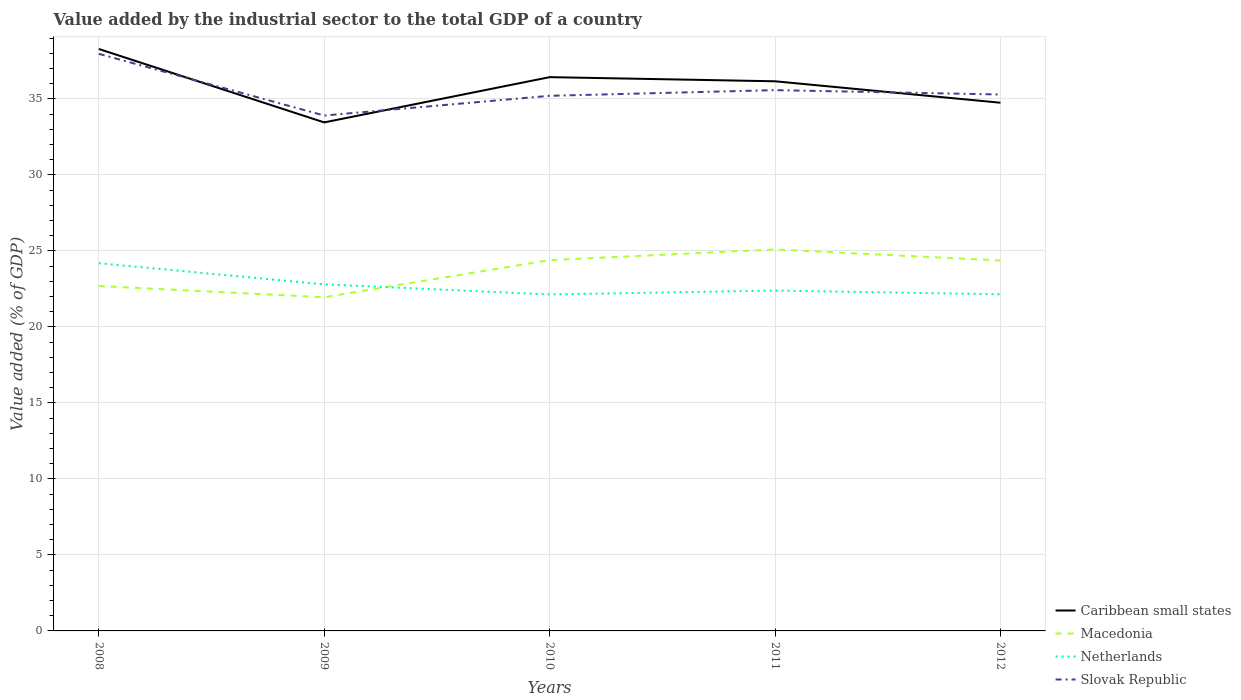How many different coloured lines are there?
Make the answer very short. 4. Is the number of lines equal to the number of legend labels?
Provide a short and direct response. Yes. Across all years, what is the maximum value added by the industrial sector to the total GDP in Slovak Republic?
Offer a very short reply. 33.91. What is the total value added by the industrial sector to the total GDP in Caribbean small states in the graph?
Keep it short and to the point. 4.83. What is the difference between the highest and the second highest value added by the industrial sector to the total GDP in Netherlands?
Your answer should be very brief. 2.05. What is the difference between the highest and the lowest value added by the industrial sector to the total GDP in Caribbean small states?
Offer a terse response. 3. Are the values on the major ticks of Y-axis written in scientific E-notation?
Provide a succinct answer. No. Does the graph contain grids?
Offer a terse response. Yes. How many legend labels are there?
Your answer should be very brief. 4. How are the legend labels stacked?
Offer a very short reply. Vertical. What is the title of the graph?
Provide a succinct answer. Value added by the industrial sector to the total GDP of a country. Does "Slovenia" appear as one of the legend labels in the graph?
Provide a short and direct response. No. What is the label or title of the X-axis?
Give a very brief answer. Years. What is the label or title of the Y-axis?
Your answer should be very brief. Value added (% of GDP). What is the Value added (% of GDP) of Caribbean small states in 2008?
Your answer should be very brief. 38.28. What is the Value added (% of GDP) in Macedonia in 2008?
Provide a short and direct response. 22.69. What is the Value added (% of GDP) of Netherlands in 2008?
Your answer should be compact. 24.19. What is the Value added (% of GDP) of Slovak Republic in 2008?
Your answer should be very brief. 37.97. What is the Value added (% of GDP) in Caribbean small states in 2009?
Your answer should be very brief. 33.45. What is the Value added (% of GDP) of Macedonia in 2009?
Ensure brevity in your answer.  21.95. What is the Value added (% of GDP) in Netherlands in 2009?
Ensure brevity in your answer.  22.8. What is the Value added (% of GDP) of Slovak Republic in 2009?
Keep it short and to the point. 33.91. What is the Value added (% of GDP) of Caribbean small states in 2010?
Make the answer very short. 36.43. What is the Value added (% of GDP) of Macedonia in 2010?
Provide a succinct answer. 24.4. What is the Value added (% of GDP) of Netherlands in 2010?
Your response must be concise. 22.14. What is the Value added (% of GDP) of Slovak Republic in 2010?
Your answer should be compact. 35.2. What is the Value added (% of GDP) of Caribbean small states in 2011?
Your answer should be very brief. 36.16. What is the Value added (% of GDP) in Macedonia in 2011?
Your answer should be very brief. 25.1. What is the Value added (% of GDP) of Netherlands in 2011?
Give a very brief answer. 22.39. What is the Value added (% of GDP) of Slovak Republic in 2011?
Give a very brief answer. 35.58. What is the Value added (% of GDP) of Caribbean small states in 2012?
Your answer should be compact. 34.75. What is the Value added (% of GDP) of Macedonia in 2012?
Offer a very short reply. 24.37. What is the Value added (% of GDP) in Netherlands in 2012?
Offer a very short reply. 22.14. What is the Value added (% of GDP) in Slovak Republic in 2012?
Make the answer very short. 35.29. Across all years, what is the maximum Value added (% of GDP) in Caribbean small states?
Keep it short and to the point. 38.28. Across all years, what is the maximum Value added (% of GDP) in Macedonia?
Give a very brief answer. 25.1. Across all years, what is the maximum Value added (% of GDP) of Netherlands?
Offer a very short reply. 24.19. Across all years, what is the maximum Value added (% of GDP) of Slovak Republic?
Offer a terse response. 37.97. Across all years, what is the minimum Value added (% of GDP) in Caribbean small states?
Your answer should be compact. 33.45. Across all years, what is the minimum Value added (% of GDP) in Macedonia?
Your response must be concise. 21.95. Across all years, what is the minimum Value added (% of GDP) in Netherlands?
Your answer should be compact. 22.14. Across all years, what is the minimum Value added (% of GDP) of Slovak Republic?
Your answer should be compact. 33.91. What is the total Value added (% of GDP) in Caribbean small states in the graph?
Ensure brevity in your answer.  179.08. What is the total Value added (% of GDP) of Macedonia in the graph?
Provide a short and direct response. 118.5. What is the total Value added (% of GDP) in Netherlands in the graph?
Give a very brief answer. 113.66. What is the total Value added (% of GDP) in Slovak Republic in the graph?
Offer a terse response. 177.94. What is the difference between the Value added (% of GDP) of Caribbean small states in 2008 and that in 2009?
Your response must be concise. 4.83. What is the difference between the Value added (% of GDP) in Macedonia in 2008 and that in 2009?
Offer a terse response. 0.74. What is the difference between the Value added (% of GDP) of Netherlands in 2008 and that in 2009?
Ensure brevity in your answer.  1.39. What is the difference between the Value added (% of GDP) of Slovak Republic in 2008 and that in 2009?
Give a very brief answer. 4.06. What is the difference between the Value added (% of GDP) in Caribbean small states in 2008 and that in 2010?
Your answer should be very brief. 1.85. What is the difference between the Value added (% of GDP) of Macedonia in 2008 and that in 2010?
Your answer should be compact. -1.7. What is the difference between the Value added (% of GDP) in Netherlands in 2008 and that in 2010?
Your answer should be compact. 2.05. What is the difference between the Value added (% of GDP) in Slovak Republic in 2008 and that in 2010?
Your answer should be compact. 2.76. What is the difference between the Value added (% of GDP) of Caribbean small states in 2008 and that in 2011?
Your answer should be very brief. 2.12. What is the difference between the Value added (% of GDP) in Macedonia in 2008 and that in 2011?
Your response must be concise. -2.41. What is the difference between the Value added (% of GDP) of Netherlands in 2008 and that in 2011?
Offer a very short reply. 1.8. What is the difference between the Value added (% of GDP) in Slovak Republic in 2008 and that in 2011?
Your answer should be compact. 2.39. What is the difference between the Value added (% of GDP) in Caribbean small states in 2008 and that in 2012?
Keep it short and to the point. 3.54. What is the difference between the Value added (% of GDP) in Macedonia in 2008 and that in 2012?
Offer a very short reply. -1.68. What is the difference between the Value added (% of GDP) in Netherlands in 2008 and that in 2012?
Give a very brief answer. 2.05. What is the difference between the Value added (% of GDP) in Slovak Republic in 2008 and that in 2012?
Ensure brevity in your answer.  2.68. What is the difference between the Value added (% of GDP) of Caribbean small states in 2009 and that in 2010?
Make the answer very short. -2.98. What is the difference between the Value added (% of GDP) in Macedonia in 2009 and that in 2010?
Provide a short and direct response. -2.44. What is the difference between the Value added (% of GDP) of Netherlands in 2009 and that in 2010?
Offer a terse response. 0.66. What is the difference between the Value added (% of GDP) in Slovak Republic in 2009 and that in 2010?
Your response must be concise. -1.3. What is the difference between the Value added (% of GDP) in Caribbean small states in 2009 and that in 2011?
Offer a terse response. -2.71. What is the difference between the Value added (% of GDP) of Macedonia in 2009 and that in 2011?
Your answer should be compact. -3.15. What is the difference between the Value added (% of GDP) of Netherlands in 2009 and that in 2011?
Make the answer very short. 0.41. What is the difference between the Value added (% of GDP) in Slovak Republic in 2009 and that in 2011?
Provide a short and direct response. -1.67. What is the difference between the Value added (% of GDP) of Caribbean small states in 2009 and that in 2012?
Ensure brevity in your answer.  -1.29. What is the difference between the Value added (% of GDP) of Macedonia in 2009 and that in 2012?
Your answer should be compact. -2.42. What is the difference between the Value added (% of GDP) in Netherlands in 2009 and that in 2012?
Offer a terse response. 0.66. What is the difference between the Value added (% of GDP) of Slovak Republic in 2009 and that in 2012?
Make the answer very short. -1.38. What is the difference between the Value added (% of GDP) in Caribbean small states in 2010 and that in 2011?
Provide a succinct answer. 0.27. What is the difference between the Value added (% of GDP) in Macedonia in 2010 and that in 2011?
Ensure brevity in your answer.  -0.7. What is the difference between the Value added (% of GDP) in Netherlands in 2010 and that in 2011?
Give a very brief answer. -0.25. What is the difference between the Value added (% of GDP) of Slovak Republic in 2010 and that in 2011?
Offer a terse response. -0.37. What is the difference between the Value added (% of GDP) of Caribbean small states in 2010 and that in 2012?
Keep it short and to the point. 1.68. What is the difference between the Value added (% of GDP) in Macedonia in 2010 and that in 2012?
Your response must be concise. 0.02. What is the difference between the Value added (% of GDP) of Netherlands in 2010 and that in 2012?
Offer a terse response. -0.01. What is the difference between the Value added (% of GDP) of Slovak Republic in 2010 and that in 2012?
Offer a terse response. -0.09. What is the difference between the Value added (% of GDP) of Caribbean small states in 2011 and that in 2012?
Ensure brevity in your answer.  1.41. What is the difference between the Value added (% of GDP) in Macedonia in 2011 and that in 2012?
Offer a terse response. 0.72. What is the difference between the Value added (% of GDP) of Netherlands in 2011 and that in 2012?
Your answer should be very brief. 0.25. What is the difference between the Value added (% of GDP) of Slovak Republic in 2011 and that in 2012?
Keep it short and to the point. 0.29. What is the difference between the Value added (% of GDP) of Caribbean small states in 2008 and the Value added (% of GDP) of Macedonia in 2009?
Keep it short and to the point. 16.33. What is the difference between the Value added (% of GDP) in Caribbean small states in 2008 and the Value added (% of GDP) in Netherlands in 2009?
Ensure brevity in your answer.  15.48. What is the difference between the Value added (% of GDP) in Caribbean small states in 2008 and the Value added (% of GDP) in Slovak Republic in 2009?
Offer a very short reply. 4.38. What is the difference between the Value added (% of GDP) of Macedonia in 2008 and the Value added (% of GDP) of Netherlands in 2009?
Keep it short and to the point. -0.11. What is the difference between the Value added (% of GDP) in Macedonia in 2008 and the Value added (% of GDP) in Slovak Republic in 2009?
Offer a terse response. -11.22. What is the difference between the Value added (% of GDP) of Netherlands in 2008 and the Value added (% of GDP) of Slovak Republic in 2009?
Give a very brief answer. -9.72. What is the difference between the Value added (% of GDP) of Caribbean small states in 2008 and the Value added (% of GDP) of Macedonia in 2010?
Provide a succinct answer. 13.89. What is the difference between the Value added (% of GDP) of Caribbean small states in 2008 and the Value added (% of GDP) of Netherlands in 2010?
Give a very brief answer. 16.15. What is the difference between the Value added (% of GDP) in Caribbean small states in 2008 and the Value added (% of GDP) in Slovak Republic in 2010?
Ensure brevity in your answer.  3.08. What is the difference between the Value added (% of GDP) in Macedonia in 2008 and the Value added (% of GDP) in Netherlands in 2010?
Provide a short and direct response. 0.55. What is the difference between the Value added (% of GDP) in Macedonia in 2008 and the Value added (% of GDP) in Slovak Republic in 2010?
Ensure brevity in your answer.  -12.51. What is the difference between the Value added (% of GDP) of Netherlands in 2008 and the Value added (% of GDP) of Slovak Republic in 2010?
Provide a succinct answer. -11.02. What is the difference between the Value added (% of GDP) of Caribbean small states in 2008 and the Value added (% of GDP) of Macedonia in 2011?
Keep it short and to the point. 13.19. What is the difference between the Value added (% of GDP) of Caribbean small states in 2008 and the Value added (% of GDP) of Netherlands in 2011?
Provide a succinct answer. 15.89. What is the difference between the Value added (% of GDP) in Caribbean small states in 2008 and the Value added (% of GDP) in Slovak Republic in 2011?
Offer a terse response. 2.71. What is the difference between the Value added (% of GDP) of Macedonia in 2008 and the Value added (% of GDP) of Netherlands in 2011?
Offer a terse response. 0.3. What is the difference between the Value added (% of GDP) in Macedonia in 2008 and the Value added (% of GDP) in Slovak Republic in 2011?
Ensure brevity in your answer.  -12.89. What is the difference between the Value added (% of GDP) in Netherlands in 2008 and the Value added (% of GDP) in Slovak Republic in 2011?
Provide a succinct answer. -11.39. What is the difference between the Value added (% of GDP) in Caribbean small states in 2008 and the Value added (% of GDP) in Macedonia in 2012?
Keep it short and to the point. 13.91. What is the difference between the Value added (% of GDP) of Caribbean small states in 2008 and the Value added (% of GDP) of Netherlands in 2012?
Your answer should be very brief. 16.14. What is the difference between the Value added (% of GDP) of Caribbean small states in 2008 and the Value added (% of GDP) of Slovak Republic in 2012?
Your answer should be compact. 2.99. What is the difference between the Value added (% of GDP) of Macedonia in 2008 and the Value added (% of GDP) of Netherlands in 2012?
Your answer should be very brief. 0.55. What is the difference between the Value added (% of GDP) of Macedonia in 2008 and the Value added (% of GDP) of Slovak Republic in 2012?
Offer a very short reply. -12.6. What is the difference between the Value added (% of GDP) in Netherlands in 2008 and the Value added (% of GDP) in Slovak Republic in 2012?
Provide a succinct answer. -11.1. What is the difference between the Value added (% of GDP) in Caribbean small states in 2009 and the Value added (% of GDP) in Macedonia in 2010?
Provide a short and direct response. 9.06. What is the difference between the Value added (% of GDP) in Caribbean small states in 2009 and the Value added (% of GDP) in Netherlands in 2010?
Give a very brief answer. 11.32. What is the difference between the Value added (% of GDP) in Caribbean small states in 2009 and the Value added (% of GDP) in Slovak Republic in 2010?
Ensure brevity in your answer.  -1.75. What is the difference between the Value added (% of GDP) of Macedonia in 2009 and the Value added (% of GDP) of Netherlands in 2010?
Keep it short and to the point. -0.19. What is the difference between the Value added (% of GDP) in Macedonia in 2009 and the Value added (% of GDP) in Slovak Republic in 2010?
Ensure brevity in your answer.  -13.25. What is the difference between the Value added (% of GDP) in Netherlands in 2009 and the Value added (% of GDP) in Slovak Republic in 2010?
Provide a succinct answer. -12.4. What is the difference between the Value added (% of GDP) in Caribbean small states in 2009 and the Value added (% of GDP) in Macedonia in 2011?
Your answer should be very brief. 8.36. What is the difference between the Value added (% of GDP) in Caribbean small states in 2009 and the Value added (% of GDP) in Netherlands in 2011?
Your response must be concise. 11.06. What is the difference between the Value added (% of GDP) of Caribbean small states in 2009 and the Value added (% of GDP) of Slovak Republic in 2011?
Give a very brief answer. -2.12. What is the difference between the Value added (% of GDP) in Macedonia in 2009 and the Value added (% of GDP) in Netherlands in 2011?
Make the answer very short. -0.44. What is the difference between the Value added (% of GDP) in Macedonia in 2009 and the Value added (% of GDP) in Slovak Republic in 2011?
Provide a succinct answer. -13.63. What is the difference between the Value added (% of GDP) in Netherlands in 2009 and the Value added (% of GDP) in Slovak Republic in 2011?
Ensure brevity in your answer.  -12.78. What is the difference between the Value added (% of GDP) of Caribbean small states in 2009 and the Value added (% of GDP) of Macedonia in 2012?
Keep it short and to the point. 9.08. What is the difference between the Value added (% of GDP) in Caribbean small states in 2009 and the Value added (% of GDP) in Netherlands in 2012?
Offer a very short reply. 11.31. What is the difference between the Value added (% of GDP) in Caribbean small states in 2009 and the Value added (% of GDP) in Slovak Republic in 2012?
Give a very brief answer. -1.84. What is the difference between the Value added (% of GDP) in Macedonia in 2009 and the Value added (% of GDP) in Netherlands in 2012?
Give a very brief answer. -0.19. What is the difference between the Value added (% of GDP) in Macedonia in 2009 and the Value added (% of GDP) in Slovak Republic in 2012?
Provide a short and direct response. -13.34. What is the difference between the Value added (% of GDP) in Netherlands in 2009 and the Value added (% of GDP) in Slovak Republic in 2012?
Offer a very short reply. -12.49. What is the difference between the Value added (% of GDP) of Caribbean small states in 2010 and the Value added (% of GDP) of Macedonia in 2011?
Offer a terse response. 11.34. What is the difference between the Value added (% of GDP) of Caribbean small states in 2010 and the Value added (% of GDP) of Netherlands in 2011?
Provide a short and direct response. 14.04. What is the difference between the Value added (% of GDP) of Caribbean small states in 2010 and the Value added (% of GDP) of Slovak Republic in 2011?
Give a very brief answer. 0.85. What is the difference between the Value added (% of GDP) in Macedonia in 2010 and the Value added (% of GDP) in Netherlands in 2011?
Your answer should be very brief. 2. What is the difference between the Value added (% of GDP) of Macedonia in 2010 and the Value added (% of GDP) of Slovak Republic in 2011?
Provide a succinct answer. -11.18. What is the difference between the Value added (% of GDP) of Netherlands in 2010 and the Value added (% of GDP) of Slovak Republic in 2011?
Keep it short and to the point. -13.44. What is the difference between the Value added (% of GDP) in Caribbean small states in 2010 and the Value added (% of GDP) in Macedonia in 2012?
Make the answer very short. 12.06. What is the difference between the Value added (% of GDP) of Caribbean small states in 2010 and the Value added (% of GDP) of Netherlands in 2012?
Your answer should be very brief. 14.29. What is the difference between the Value added (% of GDP) in Caribbean small states in 2010 and the Value added (% of GDP) in Slovak Republic in 2012?
Make the answer very short. 1.14. What is the difference between the Value added (% of GDP) in Macedonia in 2010 and the Value added (% of GDP) in Netherlands in 2012?
Your answer should be very brief. 2.25. What is the difference between the Value added (% of GDP) of Macedonia in 2010 and the Value added (% of GDP) of Slovak Republic in 2012?
Offer a terse response. -10.89. What is the difference between the Value added (% of GDP) of Netherlands in 2010 and the Value added (% of GDP) of Slovak Republic in 2012?
Your response must be concise. -13.15. What is the difference between the Value added (% of GDP) in Caribbean small states in 2011 and the Value added (% of GDP) in Macedonia in 2012?
Offer a very short reply. 11.79. What is the difference between the Value added (% of GDP) in Caribbean small states in 2011 and the Value added (% of GDP) in Netherlands in 2012?
Offer a very short reply. 14.02. What is the difference between the Value added (% of GDP) of Caribbean small states in 2011 and the Value added (% of GDP) of Slovak Republic in 2012?
Provide a short and direct response. 0.87. What is the difference between the Value added (% of GDP) in Macedonia in 2011 and the Value added (% of GDP) in Netherlands in 2012?
Ensure brevity in your answer.  2.95. What is the difference between the Value added (% of GDP) of Macedonia in 2011 and the Value added (% of GDP) of Slovak Republic in 2012?
Keep it short and to the point. -10.19. What is the difference between the Value added (% of GDP) in Netherlands in 2011 and the Value added (% of GDP) in Slovak Republic in 2012?
Your answer should be compact. -12.9. What is the average Value added (% of GDP) of Caribbean small states per year?
Offer a very short reply. 35.82. What is the average Value added (% of GDP) of Macedonia per year?
Make the answer very short. 23.7. What is the average Value added (% of GDP) in Netherlands per year?
Give a very brief answer. 22.73. What is the average Value added (% of GDP) of Slovak Republic per year?
Your answer should be very brief. 35.59. In the year 2008, what is the difference between the Value added (% of GDP) of Caribbean small states and Value added (% of GDP) of Macedonia?
Offer a very short reply. 15.59. In the year 2008, what is the difference between the Value added (% of GDP) of Caribbean small states and Value added (% of GDP) of Netherlands?
Keep it short and to the point. 14.1. In the year 2008, what is the difference between the Value added (% of GDP) of Caribbean small states and Value added (% of GDP) of Slovak Republic?
Offer a very short reply. 0.32. In the year 2008, what is the difference between the Value added (% of GDP) in Macedonia and Value added (% of GDP) in Netherlands?
Give a very brief answer. -1.5. In the year 2008, what is the difference between the Value added (% of GDP) in Macedonia and Value added (% of GDP) in Slovak Republic?
Offer a very short reply. -15.28. In the year 2008, what is the difference between the Value added (% of GDP) of Netherlands and Value added (% of GDP) of Slovak Republic?
Make the answer very short. -13.78. In the year 2009, what is the difference between the Value added (% of GDP) in Caribbean small states and Value added (% of GDP) in Macedonia?
Provide a short and direct response. 11.5. In the year 2009, what is the difference between the Value added (% of GDP) in Caribbean small states and Value added (% of GDP) in Netherlands?
Offer a terse response. 10.65. In the year 2009, what is the difference between the Value added (% of GDP) in Caribbean small states and Value added (% of GDP) in Slovak Republic?
Provide a short and direct response. -0.45. In the year 2009, what is the difference between the Value added (% of GDP) in Macedonia and Value added (% of GDP) in Netherlands?
Your answer should be compact. -0.85. In the year 2009, what is the difference between the Value added (% of GDP) of Macedonia and Value added (% of GDP) of Slovak Republic?
Offer a terse response. -11.96. In the year 2009, what is the difference between the Value added (% of GDP) in Netherlands and Value added (% of GDP) in Slovak Republic?
Keep it short and to the point. -11.11. In the year 2010, what is the difference between the Value added (% of GDP) of Caribbean small states and Value added (% of GDP) of Macedonia?
Provide a short and direct response. 12.04. In the year 2010, what is the difference between the Value added (% of GDP) of Caribbean small states and Value added (% of GDP) of Netherlands?
Provide a succinct answer. 14.3. In the year 2010, what is the difference between the Value added (% of GDP) of Caribbean small states and Value added (% of GDP) of Slovak Republic?
Provide a short and direct response. 1.23. In the year 2010, what is the difference between the Value added (% of GDP) in Macedonia and Value added (% of GDP) in Netherlands?
Ensure brevity in your answer.  2.26. In the year 2010, what is the difference between the Value added (% of GDP) of Macedonia and Value added (% of GDP) of Slovak Republic?
Your answer should be compact. -10.81. In the year 2010, what is the difference between the Value added (% of GDP) of Netherlands and Value added (% of GDP) of Slovak Republic?
Your answer should be very brief. -13.07. In the year 2011, what is the difference between the Value added (% of GDP) in Caribbean small states and Value added (% of GDP) in Macedonia?
Provide a succinct answer. 11.06. In the year 2011, what is the difference between the Value added (% of GDP) of Caribbean small states and Value added (% of GDP) of Netherlands?
Ensure brevity in your answer.  13.77. In the year 2011, what is the difference between the Value added (% of GDP) of Caribbean small states and Value added (% of GDP) of Slovak Republic?
Offer a terse response. 0.58. In the year 2011, what is the difference between the Value added (% of GDP) in Macedonia and Value added (% of GDP) in Netherlands?
Keep it short and to the point. 2.71. In the year 2011, what is the difference between the Value added (% of GDP) of Macedonia and Value added (% of GDP) of Slovak Republic?
Ensure brevity in your answer.  -10.48. In the year 2011, what is the difference between the Value added (% of GDP) in Netherlands and Value added (% of GDP) in Slovak Republic?
Offer a very short reply. -13.19. In the year 2012, what is the difference between the Value added (% of GDP) in Caribbean small states and Value added (% of GDP) in Macedonia?
Keep it short and to the point. 10.38. In the year 2012, what is the difference between the Value added (% of GDP) of Caribbean small states and Value added (% of GDP) of Netherlands?
Ensure brevity in your answer.  12.6. In the year 2012, what is the difference between the Value added (% of GDP) of Caribbean small states and Value added (% of GDP) of Slovak Republic?
Offer a very short reply. -0.54. In the year 2012, what is the difference between the Value added (% of GDP) of Macedonia and Value added (% of GDP) of Netherlands?
Offer a very short reply. 2.23. In the year 2012, what is the difference between the Value added (% of GDP) in Macedonia and Value added (% of GDP) in Slovak Republic?
Your response must be concise. -10.92. In the year 2012, what is the difference between the Value added (% of GDP) of Netherlands and Value added (% of GDP) of Slovak Republic?
Provide a succinct answer. -13.15. What is the ratio of the Value added (% of GDP) of Caribbean small states in 2008 to that in 2009?
Your answer should be compact. 1.14. What is the ratio of the Value added (% of GDP) in Macedonia in 2008 to that in 2009?
Give a very brief answer. 1.03. What is the ratio of the Value added (% of GDP) in Netherlands in 2008 to that in 2009?
Ensure brevity in your answer.  1.06. What is the ratio of the Value added (% of GDP) of Slovak Republic in 2008 to that in 2009?
Offer a very short reply. 1.12. What is the ratio of the Value added (% of GDP) in Caribbean small states in 2008 to that in 2010?
Your response must be concise. 1.05. What is the ratio of the Value added (% of GDP) in Macedonia in 2008 to that in 2010?
Your answer should be very brief. 0.93. What is the ratio of the Value added (% of GDP) in Netherlands in 2008 to that in 2010?
Ensure brevity in your answer.  1.09. What is the ratio of the Value added (% of GDP) of Slovak Republic in 2008 to that in 2010?
Provide a short and direct response. 1.08. What is the ratio of the Value added (% of GDP) of Caribbean small states in 2008 to that in 2011?
Make the answer very short. 1.06. What is the ratio of the Value added (% of GDP) in Macedonia in 2008 to that in 2011?
Give a very brief answer. 0.9. What is the ratio of the Value added (% of GDP) of Netherlands in 2008 to that in 2011?
Your answer should be compact. 1.08. What is the ratio of the Value added (% of GDP) of Slovak Republic in 2008 to that in 2011?
Ensure brevity in your answer.  1.07. What is the ratio of the Value added (% of GDP) in Caribbean small states in 2008 to that in 2012?
Ensure brevity in your answer.  1.1. What is the ratio of the Value added (% of GDP) in Macedonia in 2008 to that in 2012?
Offer a very short reply. 0.93. What is the ratio of the Value added (% of GDP) in Netherlands in 2008 to that in 2012?
Your response must be concise. 1.09. What is the ratio of the Value added (% of GDP) in Slovak Republic in 2008 to that in 2012?
Your response must be concise. 1.08. What is the ratio of the Value added (% of GDP) in Caribbean small states in 2009 to that in 2010?
Make the answer very short. 0.92. What is the ratio of the Value added (% of GDP) of Macedonia in 2009 to that in 2010?
Your answer should be compact. 0.9. What is the ratio of the Value added (% of GDP) of Slovak Republic in 2009 to that in 2010?
Ensure brevity in your answer.  0.96. What is the ratio of the Value added (% of GDP) in Caribbean small states in 2009 to that in 2011?
Your response must be concise. 0.93. What is the ratio of the Value added (% of GDP) of Macedonia in 2009 to that in 2011?
Offer a terse response. 0.87. What is the ratio of the Value added (% of GDP) in Netherlands in 2009 to that in 2011?
Give a very brief answer. 1.02. What is the ratio of the Value added (% of GDP) in Slovak Republic in 2009 to that in 2011?
Your answer should be compact. 0.95. What is the ratio of the Value added (% of GDP) in Caribbean small states in 2009 to that in 2012?
Ensure brevity in your answer.  0.96. What is the ratio of the Value added (% of GDP) in Macedonia in 2009 to that in 2012?
Your response must be concise. 0.9. What is the ratio of the Value added (% of GDP) of Netherlands in 2009 to that in 2012?
Offer a very short reply. 1.03. What is the ratio of the Value added (% of GDP) in Slovak Republic in 2009 to that in 2012?
Offer a terse response. 0.96. What is the ratio of the Value added (% of GDP) of Caribbean small states in 2010 to that in 2011?
Keep it short and to the point. 1.01. What is the ratio of the Value added (% of GDP) in Macedonia in 2010 to that in 2011?
Make the answer very short. 0.97. What is the ratio of the Value added (% of GDP) of Netherlands in 2010 to that in 2011?
Ensure brevity in your answer.  0.99. What is the ratio of the Value added (% of GDP) in Slovak Republic in 2010 to that in 2011?
Make the answer very short. 0.99. What is the ratio of the Value added (% of GDP) of Caribbean small states in 2010 to that in 2012?
Ensure brevity in your answer.  1.05. What is the ratio of the Value added (% of GDP) in Macedonia in 2010 to that in 2012?
Offer a very short reply. 1. What is the ratio of the Value added (% of GDP) of Netherlands in 2010 to that in 2012?
Give a very brief answer. 1. What is the ratio of the Value added (% of GDP) of Slovak Republic in 2010 to that in 2012?
Your answer should be very brief. 1. What is the ratio of the Value added (% of GDP) of Caribbean small states in 2011 to that in 2012?
Make the answer very short. 1.04. What is the ratio of the Value added (% of GDP) in Macedonia in 2011 to that in 2012?
Your answer should be compact. 1.03. What is the ratio of the Value added (% of GDP) in Netherlands in 2011 to that in 2012?
Offer a very short reply. 1.01. What is the ratio of the Value added (% of GDP) in Slovak Republic in 2011 to that in 2012?
Your answer should be compact. 1.01. What is the difference between the highest and the second highest Value added (% of GDP) in Caribbean small states?
Offer a very short reply. 1.85. What is the difference between the highest and the second highest Value added (% of GDP) of Macedonia?
Your answer should be compact. 0.7. What is the difference between the highest and the second highest Value added (% of GDP) of Netherlands?
Offer a terse response. 1.39. What is the difference between the highest and the second highest Value added (% of GDP) of Slovak Republic?
Your answer should be very brief. 2.39. What is the difference between the highest and the lowest Value added (% of GDP) of Caribbean small states?
Make the answer very short. 4.83. What is the difference between the highest and the lowest Value added (% of GDP) in Macedonia?
Your answer should be compact. 3.15. What is the difference between the highest and the lowest Value added (% of GDP) of Netherlands?
Ensure brevity in your answer.  2.05. What is the difference between the highest and the lowest Value added (% of GDP) of Slovak Republic?
Offer a terse response. 4.06. 